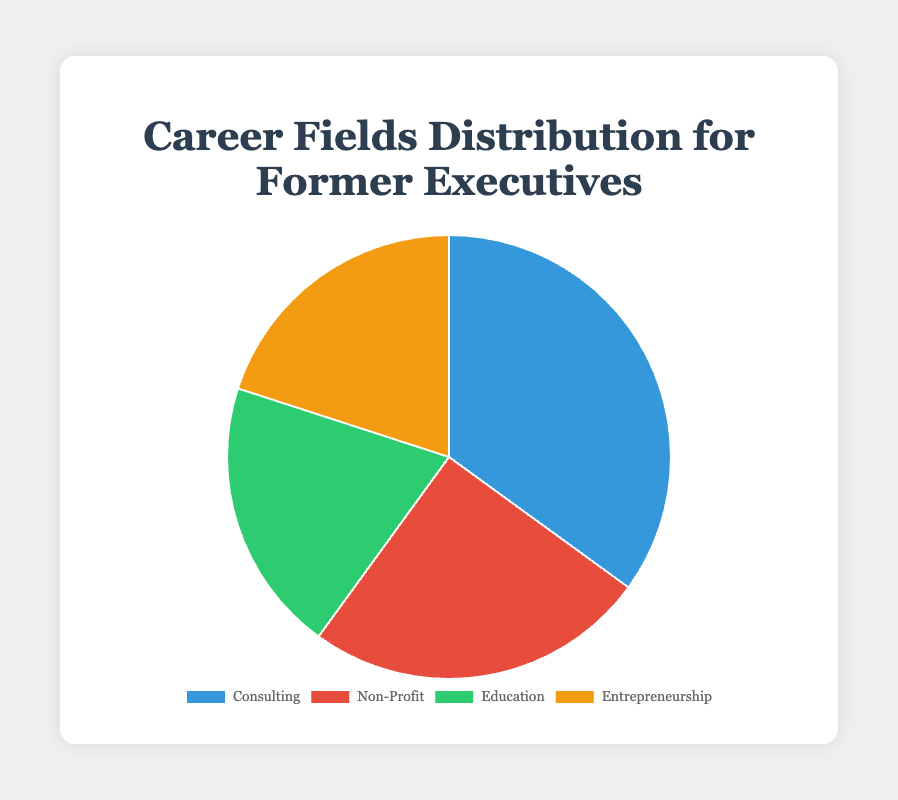What's the most common career field chosen by former executives post-retirement? By looking at the pie chart, consulting has the largest section. We can see from the slice size that it occupies more than any other section, meaning it's the most common choice.
Answer: Consulting Which career fields have equal representation among former executives? The pie chart has 4 fields, but two fields have equal representation: Education and Entrepreneurship both show 20%. We can see this because their slices are the same size.
Answer: Education and Entrepreneurship What is the combined percentage of former executives who chose Education and Non-Profit fields? The percentage for Education is 20% and for Non-Profit is 25%. Adding these two together gives us 20% + 25% = 45%.
Answer: 45% How much more popular is Consulting compared to Entrepreneurship? Consulting has a percentage of 35%, while Entrepreneurship has 20%. The difference between these is calculated as 35% - 20% = 15%.
Answer: 15% Which color represents the Non-Profit career field in the pie chart? By examining the color legend next to the Non-Profit segment, we see that the Non-Profit portion is represented in red.
Answer: Red If you were to merge the fields of Non-Profit and Entrepreneurship, what percentage of the pie chart would that new segment occupy? Non-Profit occupies 25% and Entrepreneurship occupies 20%. Merging these two would give 25% + 20% = 45%.
Answer: 45% How does the percentage of executives choosing Education compare to those choosing Consulting? Consulting is at 35% while Education is at 20%. Consulting is 35% - 20% = 15% more popular than Education.
Answer: 15% If the number of executives choosing Education doubled, what would the new percentage be? If the Education percentage doubled from 20%, it would be 2 * 20% = 40%.
Answer: 40% What is the difference in percentage points between the smallest and largest segments? The smallest segments are Education and Entrepreneurship at 20%, and the largest is Consulting at 35%. The difference is 35% - 20% = 15%.
Answer: 15% Among those who did not choose Consulting, what career field is most popular? By excluding Consulting, we compare Non-Profit (25%), Education (20%), and Entrepreneurship (20%). Non-Profit is the largest among these at 25%.
Answer: Non-Profit 